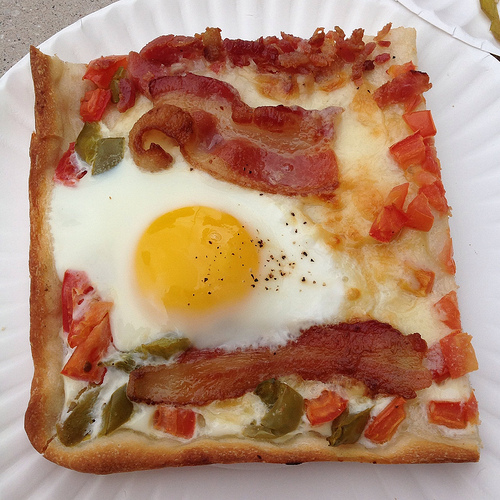Describe the different textures that can be observed on this pizza. This pizza showcases a variety of textures: the crispy, lightly charred crust; the soft, gooey melted cheese; the smooth, rich egg; and the crispness of fresh vegetables. How do these textures contribute to the overall taste experience? These textures combine harmoniously to deliver a multi-dimensional eating experience. The crunchiness of the crust and vegetables nicely contrasts with the softness of the cheese and egg, making each bite satisfyingly complex. 